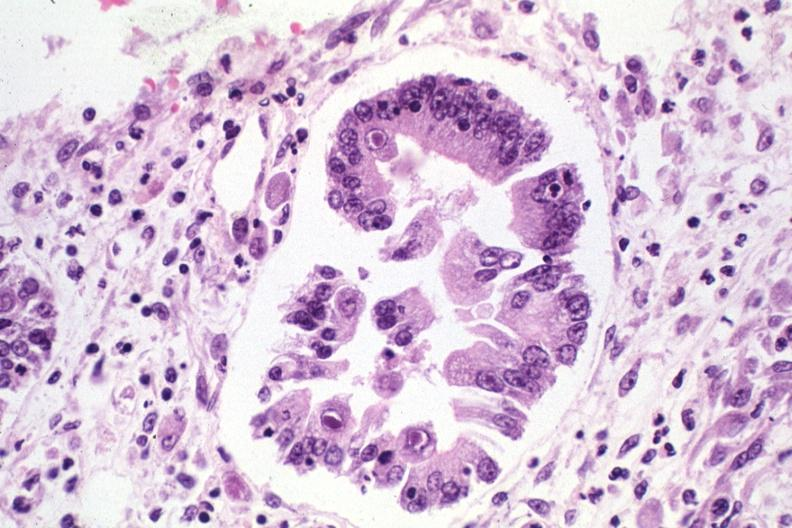s cranial artery present?
Answer the question using a single word or phrase. No 